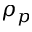<formula> <loc_0><loc_0><loc_500><loc_500>\rho _ { p }</formula> 